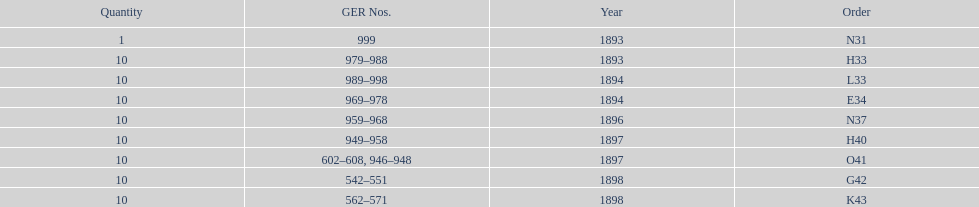When was g42, 1894 or 1898? 1898. 